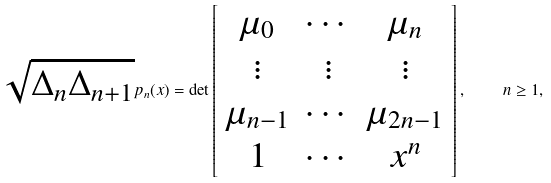<formula> <loc_0><loc_0><loc_500><loc_500>\sqrt { \Delta _ { n } \Delta _ { n + 1 } } p _ { n } ( x ) = \det \left [ \begin{array} { c c c } \mu _ { 0 } & \cdots & \mu _ { n } \\ \vdots & \vdots & \vdots \\ \mu _ { n - 1 } & \cdots & \mu _ { 2 n - 1 } \\ 1 & \cdots & x ^ { n } \\ \end{array} \right ] , \quad n \geq 1 ,</formula> 